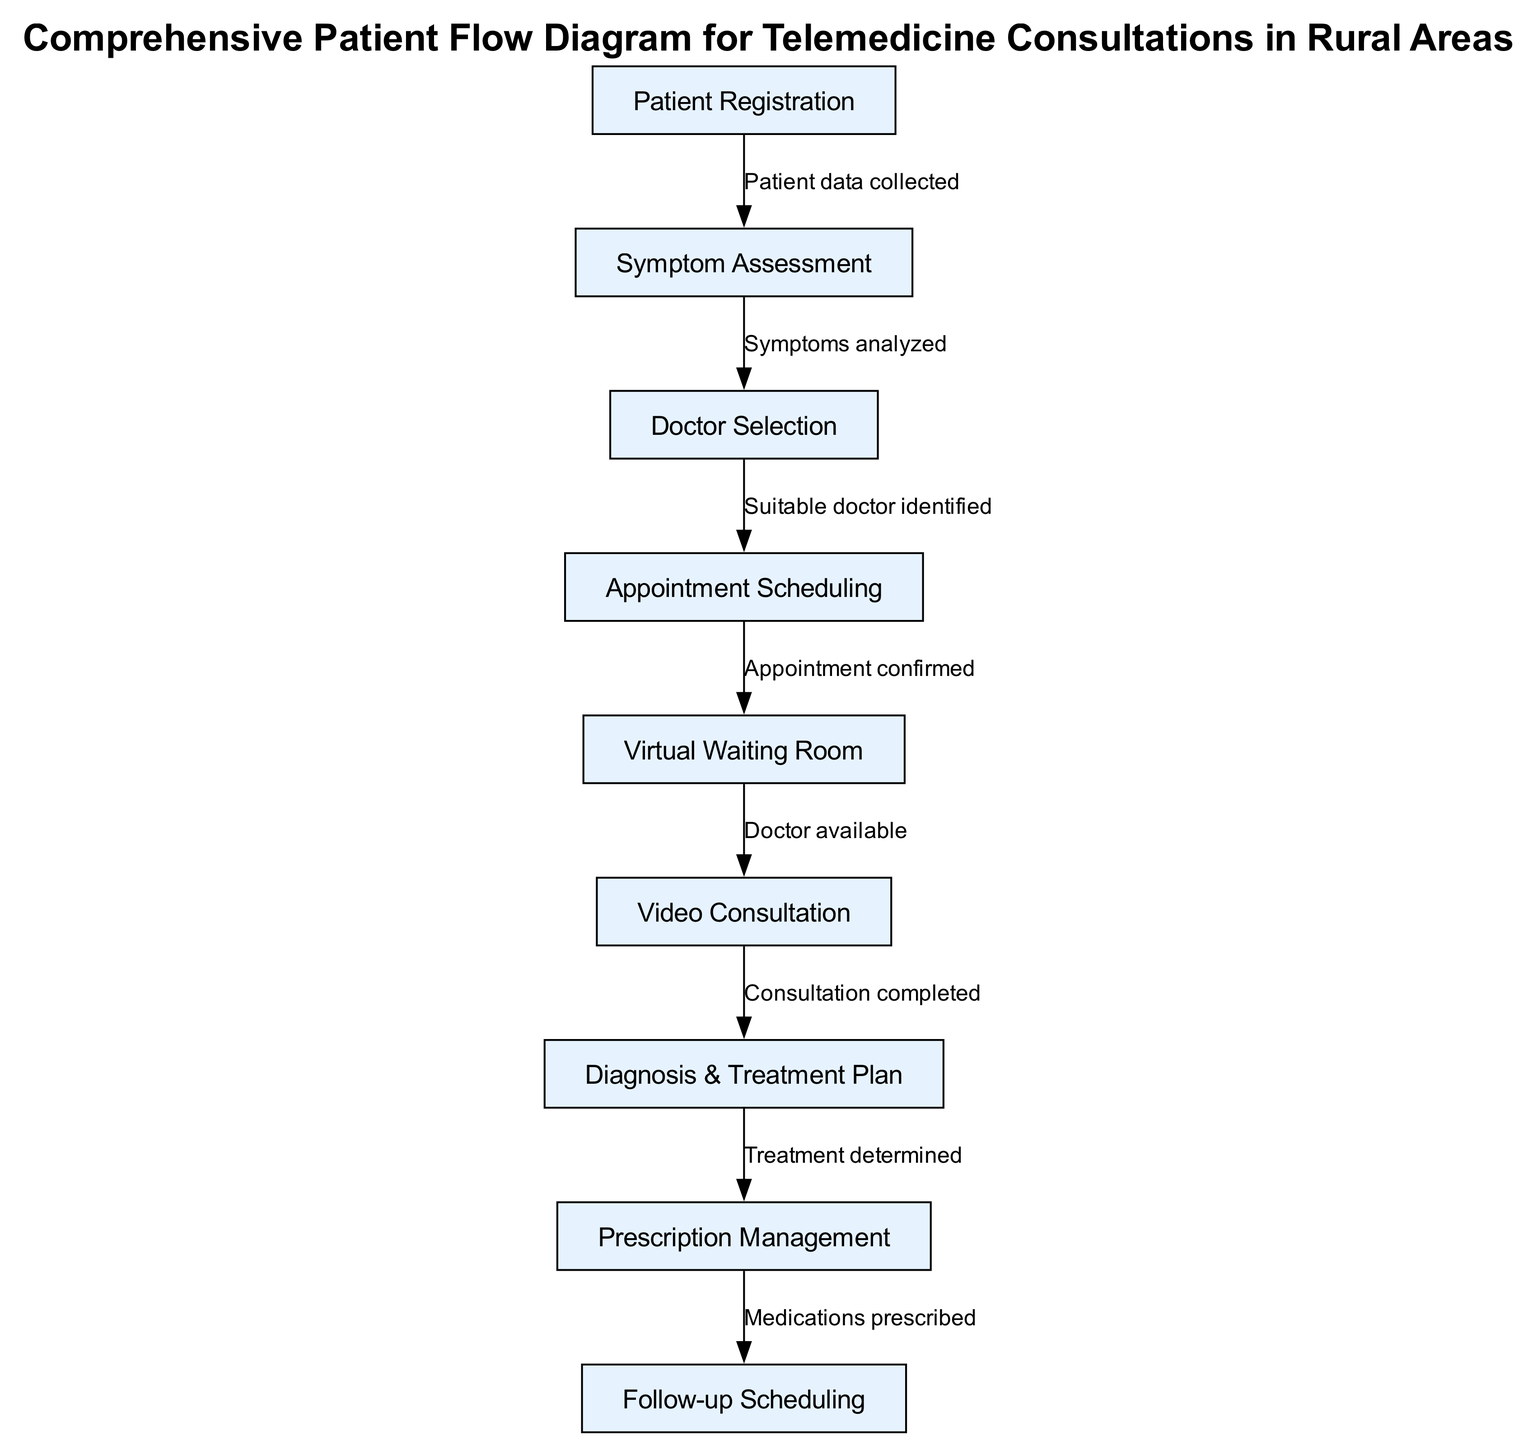What is the first step in the patient flow diagram? The first step in the diagram is "Patient Registration," which is the initial node where the patient enters the telemedicine consultation process.
Answer: Patient Registration How many nodes are present in the diagram? By counting the nodes listed in the diagram, there are a total of nine distinct steps for patient flow from registration to follow-up scheduling.
Answer: Nine Which edge connects symptom assessment to doctor selection? The edge that connects these two nodes is labeled "Symptoms analyzed," indicating that after the symptom assessment, the symptoms are analyzed to identify a suitable doctor.
Answer: Symptoms analyzed What is the last step of the consultation process? Following the flow of the diagram, the last step is "Follow-up Scheduling," which occurs after the prescription management, indicating the completion of the consultation process.
Answer: Follow-up Scheduling What happens after the video consultation is completed? After the completion of the video consultation, the next step in the flow diagram is "Diagnosis & Treatment Plan," showing the progression from consultation to the establishment of a treatment plan.
Answer: Diagnosis & Treatment Plan What is the relationship between prescription management and follow-up scheduling? The relationship is described by the edge labeled "Medications prescribed," which indicates that after managing the prescriptions, the subsequent step is to schedule a follow-up appointment.
Answer: Medications prescribed Which node precedes appointment scheduling? The diagram shows that the node "Doctor Selection" directly precedes "Appointment Scheduling," indicating that the selection of a doctor is necessary before scheduling an appointment.
Answer: Doctor Selection How many edges are there connecting the nodes? Counting the connections between the nodes, there are a total of eight edges that represent the flow of information and steps in the diagram.
Answer: Eight What label describes the connection between the virtual waiting room and video consultation? The connection between these two nodes is labeled "Doctor available," indicating that the patient waits in the virtual waiting room until the doctor becomes available for the video consultation.
Answer: Doctor available 